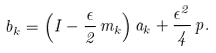Convert formula to latex. <formula><loc_0><loc_0><loc_500><loc_500>b _ { k } = \left ( I - \frac { \epsilon } { 2 } \, m _ { k } \right ) a _ { k } + \frac { \epsilon ^ { 2 } } { 4 } \, p .</formula> 